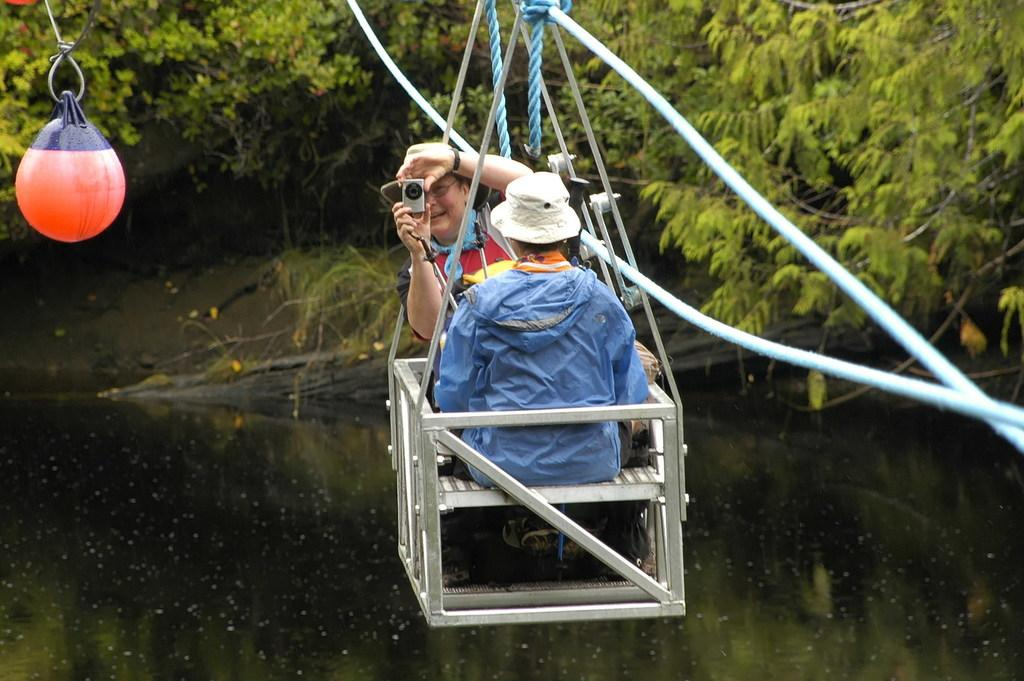What are the people in the image doing? The people in the image are sitting in the ropeway. What object is one of the people holding? One of the people is holding a camera in their hands. What can be seen in the background of the image? There are trees and water visible in the background of the image. What type of juice is being served in the ropeway? There is no juice present in the image; it only shows people sitting in the ropeway and the background elements. 